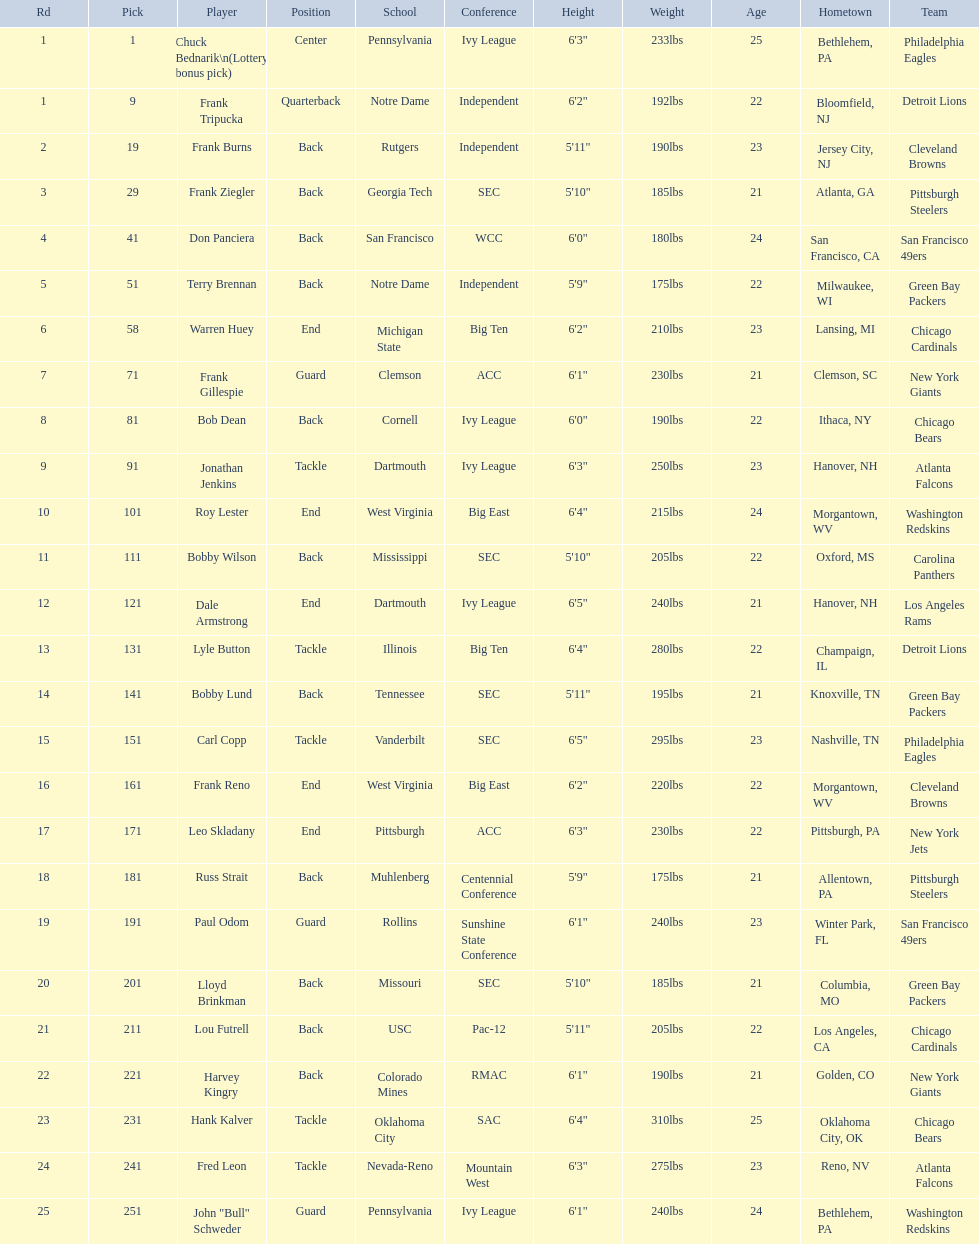Who was the player that the team drafted after bob dean? Jonathan Jenkins. 